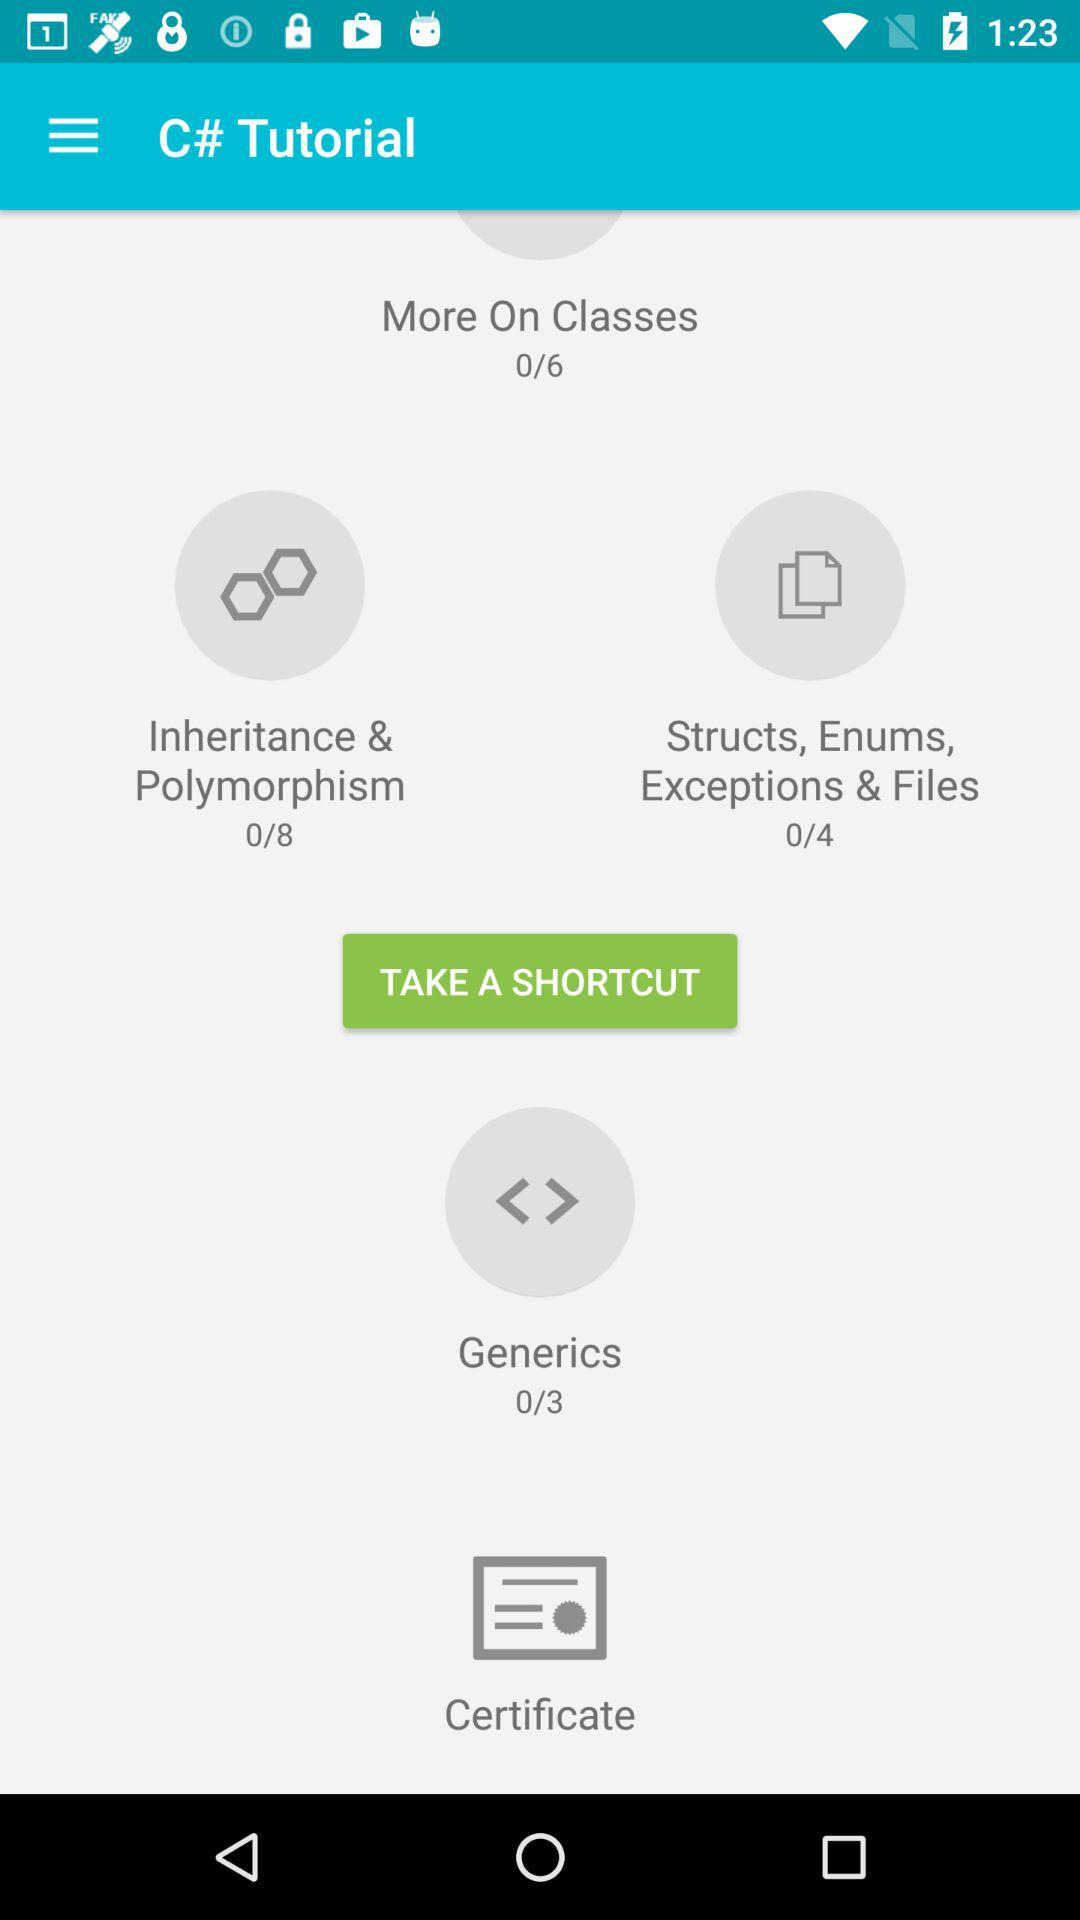What is the total number of generics? The total number of generics is 3. 